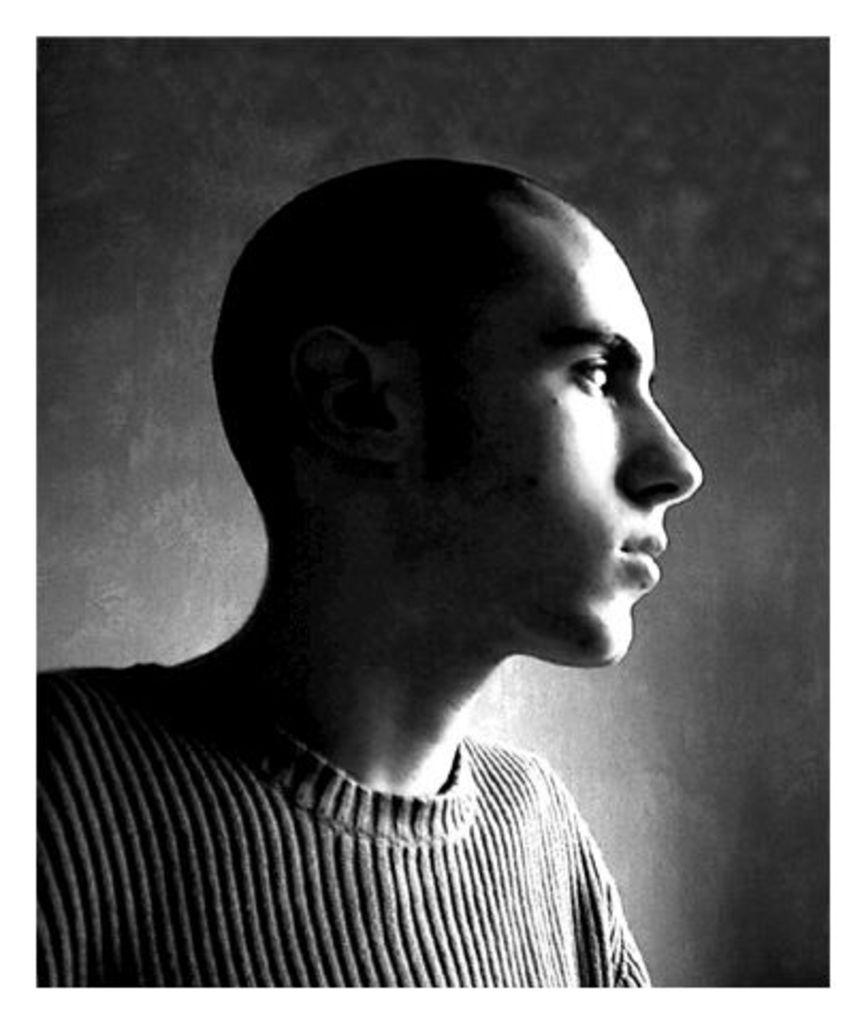What is the color scheme of the image? The image is black and white. Can you describe the main subject in the image? There is a person in the image. What can be seen in the background of the image? There is a wall in the background of the image. How many snails are crawling on the person's leather jacket in the image? There are no snails or leather jackets present in the image; it is a black and white image featuring a person with a wall in the background. 